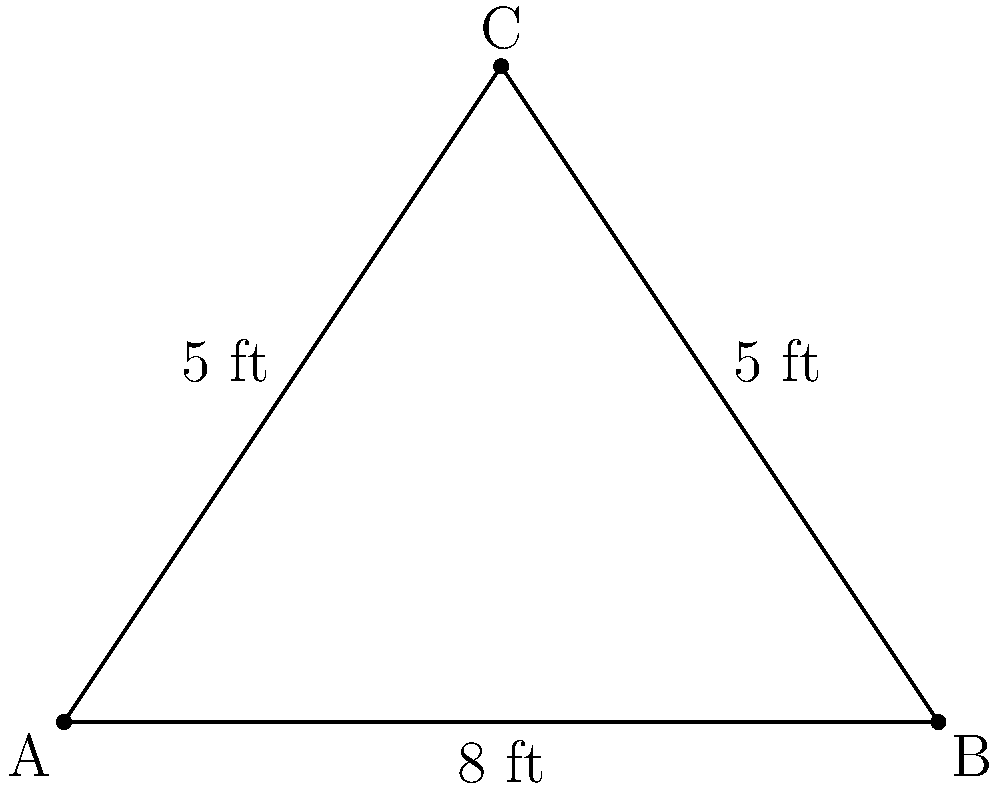In a classic horror film shot, a camera is positioned at point C, capturing a scene between two actors at points A and B. The distance between the actors is 8 feet, and the camera is 5 feet away from each actor. What is the angle of view (∠ACB) for this shot? Explain how this wide-angle perspective might contribute to the film's atmosphere without relying on visual effects. To solve this problem, we'll use the law of cosines, which is perfect for a triangle where we know all three side lengths but need to find an angle.

Step 1: Identify the known values
- AB = 8 feet (distance between actors)
- AC = 5 feet (distance from camera to actor A)
- BC = 5 feet (distance from camera to actor B)

Step 2: Apply the law of cosines
The law of cosines states: $c^2 = a^2 + b^2 - 2ab \cos(C)$
Where C is the angle we're looking for (∠ACB), and c is the side opposite to this angle (AB).

$AB^2 = AC^2 + BC^2 - 2(AC)(BC)\cos(∠ACB)$

Step 3: Substitute the known values
$8^2 = 5^2 + 5^2 - 2(5)(5)\cos(∠ACB)$

Step 4: Simplify
$64 = 25 + 25 - 50\cos(∠ACB)$
$64 = 50 - 50\cos(∠ACB)$

Step 5: Solve for $\cos(∠ACB)$
$50\cos(∠ACB) = 50 - 64 = -14$
$\cos(∠ACB) = -\frac{14}{50} = -0.28$

Step 6: Take the inverse cosine (arccos) of both sides
$∠ACB = \arccos(-0.28) \approx 106.26°$

The wide-angle perspective created by this 106.26° angle of view can contribute to the film's atmosphere by:
1. Creating a sense of unease and distortion
2. Exaggerating the depth and space between the actors
3. Allowing more of the environment to be visible, potentially revealing hidden threats
4. Emphasizing the vulnerability of the characters by making them appear smaller in the frame

These effects can enhance the horror atmosphere without relying on visual effects, demonstrating that classic cinematography techniques can be just as effective in creating tension and fear.
Answer: 106.26° 